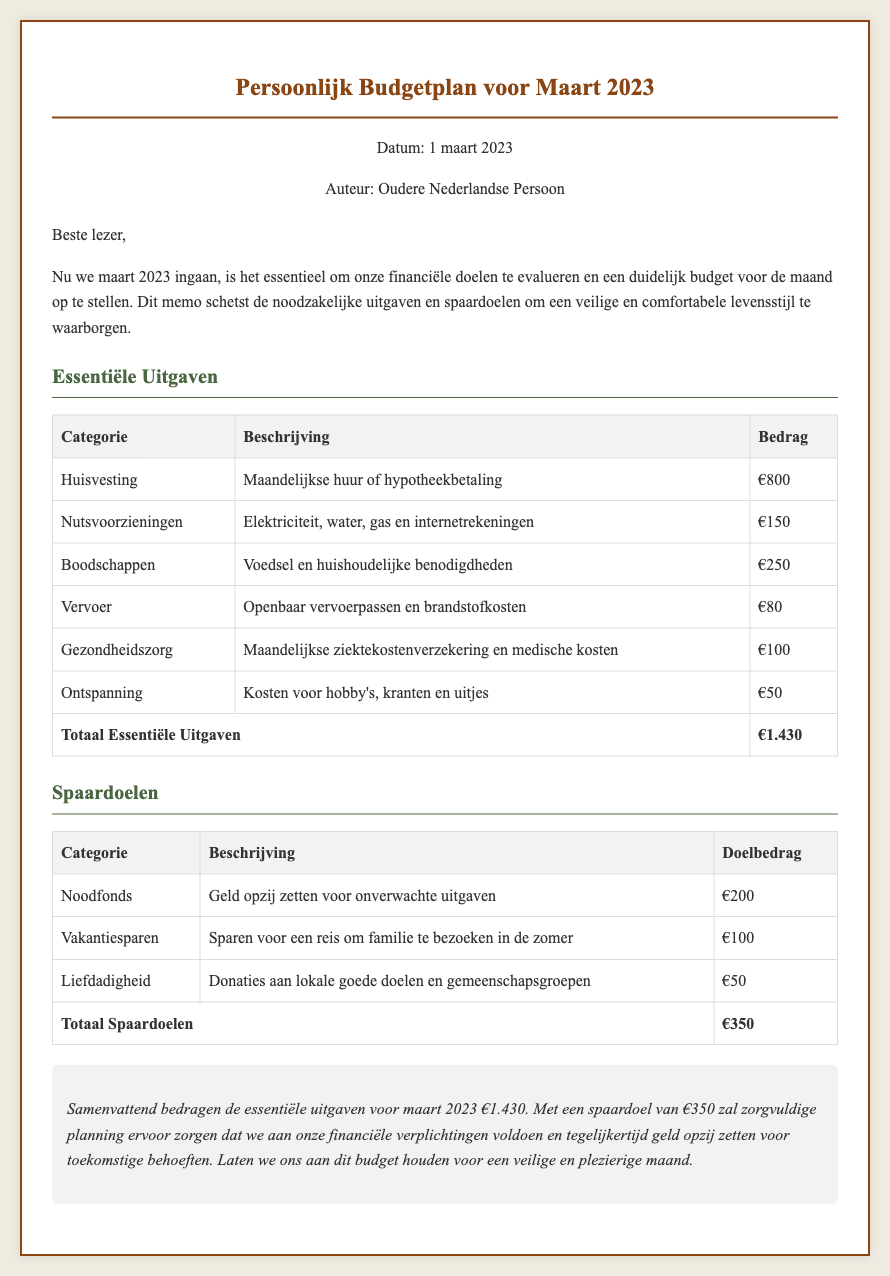wat is het totale bedrag van de essentiële uitgaven? Het totale bedrag van de essentiële uitgaven is te vinden in de tabel onder het kopje "Essentiële Uitgaven", waar het wordt vermeld als €1.430.
Answer: €1.430 hoeveel geld is bedoeld voor het noodfonds? Het doelbedrag voor het noodfonds staat in de tabel onder "Spaardoelen" vermeld, wat €200 is.
Answer: €200 wat is de datum van dit budgetplan? De datum van het budgetplan staat aan het begin van het document en is 1 maart 2023.
Answer: 1 maart 2023 welke categorie heeft de laagste uitgaven? Bij de essentiële uitgaven heeft de categorie "Ontspanning" de laagste uitgaven van €50.
Answer: Ontspanning wat is het totale doelbedrag voor spaardoelen? Het totale doelbedrag voor spaardoelen staat onder het kopje "Spaardoelen" en bedraagt €350.
Answer: €350 wat is de hoofdcategorie voor maandelijkse huur? De hoofdcategorie voor maandelijkse huur is "Huisvesting", zoals vermeld in de tabel van essentiële uitgaven.
Answer: Huisvesting hoeveel is er gereserveerd voor vakantiesparen? Het bedrag gereserveerd voor vakantiesparen is terug te vinden in de "Spaardoelen"-tabel en is €100.
Answer: €100 welke uitgaven zijn inbegrepen onder nutsvoorzieningen? De uitgaven onder nutsvoorzieningen omvatten elektriciteit, water, gas en internetrekeningen, zoals vermeld in de documentatie.
Answer: Elektriciteit, water, gas en internetrekeningen 